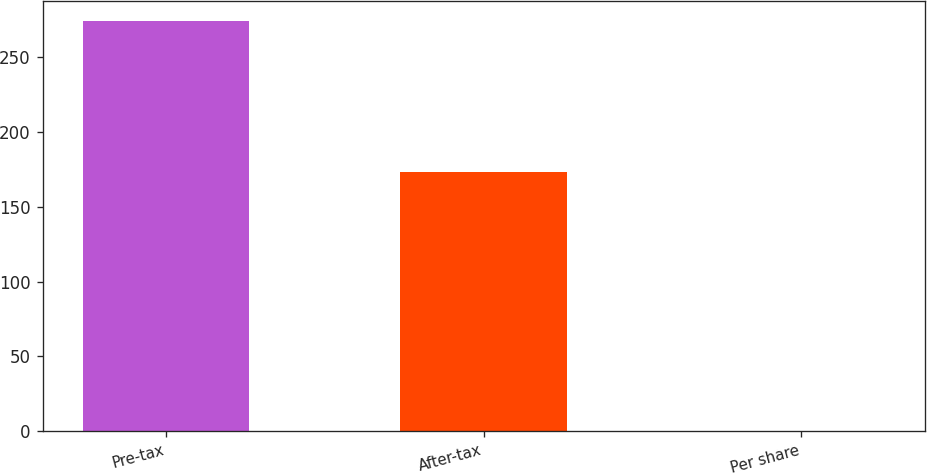Convert chart. <chart><loc_0><loc_0><loc_500><loc_500><bar_chart><fcel>Pre-tax<fcel>After-tax<fcel>Per share<nl><fcel>274<fcel>173<fcel>0.11<nl></chart> 